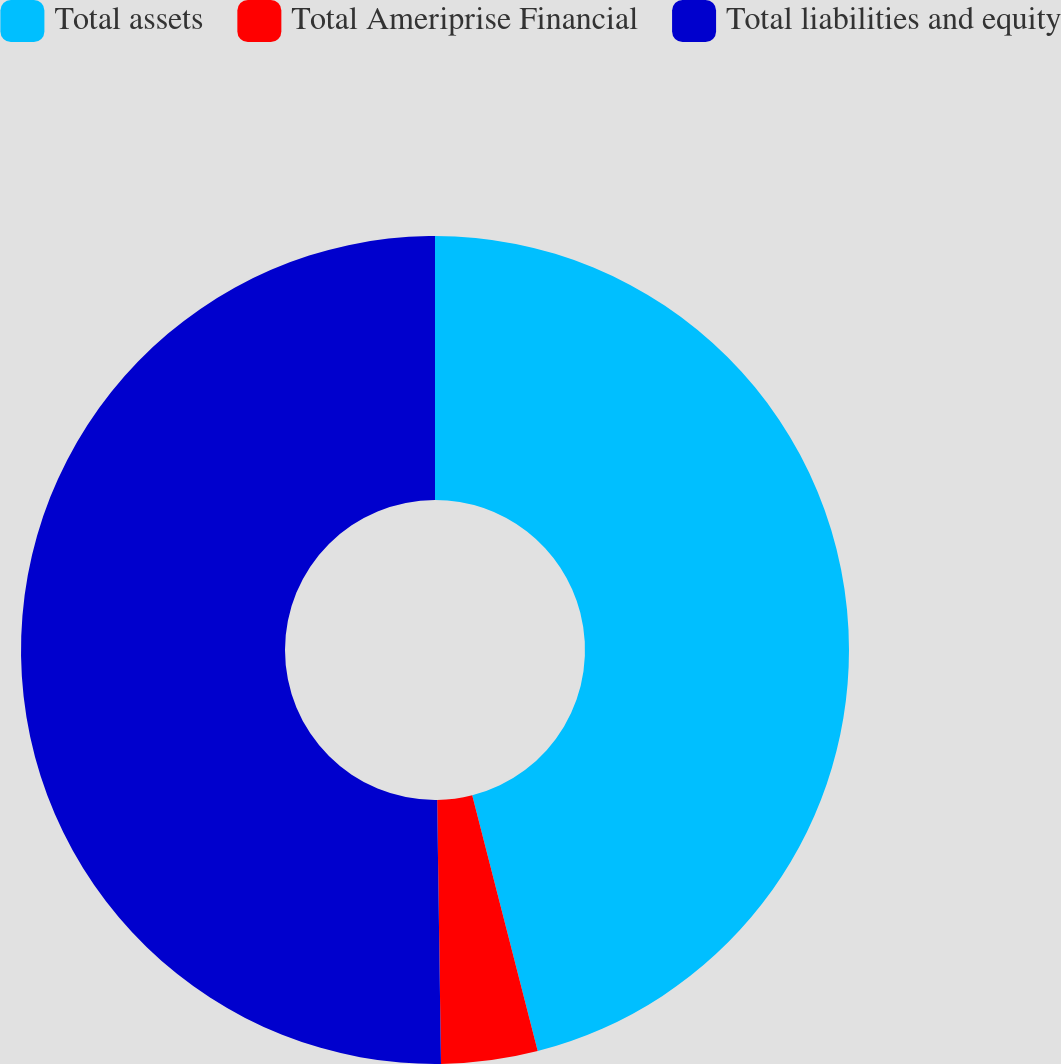Convert chart to OTSL. <chart><loc_0><loc_0><loc_500><loc_500><pie_chart><fcel>Total assets<fcel>Total Ameriprise Financial<fcel>Total liabilities and equity<nl><fcel>46.01%<fcel>3.76%<fcel>50.23%<nl></chart> 